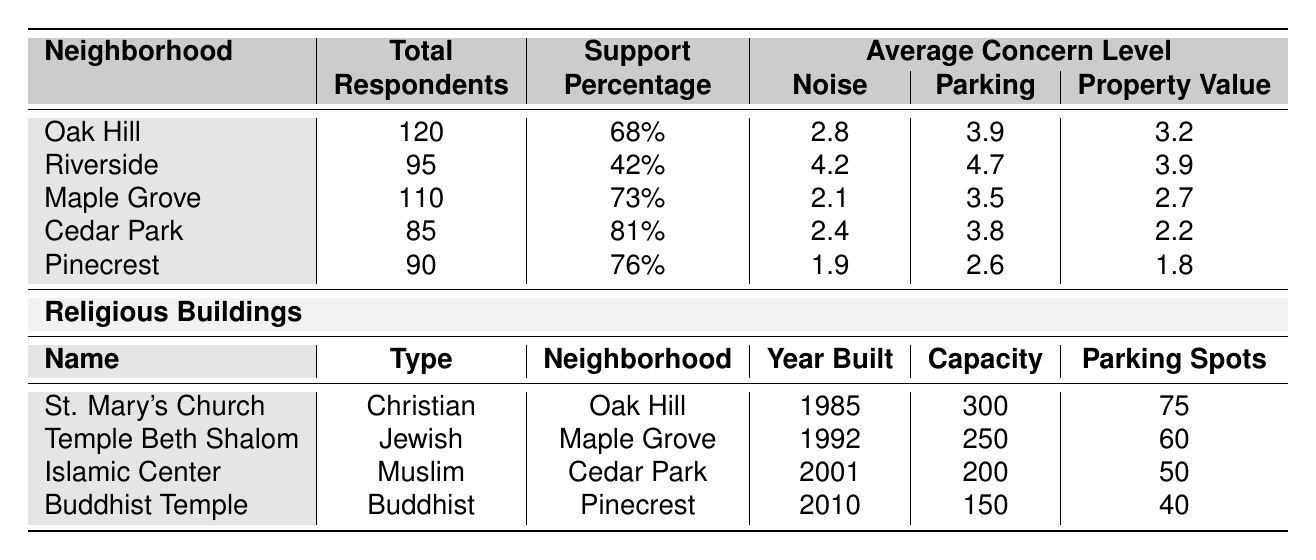What is the total number of respondents from Riverside? The table lists Riverside as having a total of 95 respondents.
Answer: 95 What percentage of respondents from Cedar Park support religious buildings? The support percentage for Cedar Park is indicated as 81%.
Answer: 81% Which neighborhood has the highest average concern about parking? Looking at the average concern levels, Riverside has the highest average concern for parking at 4.7.
Answer: Riverside What is the average concern for property value in the neighborhood of Pinecrest? The table shows that the average concern for property value in Pinecrest is 1.8.
Answer: 1.8 Which religious building has the highest capacity? St. Mary's Church has the highest capacity listed at 300.
Answer: St. Mary's Church How many more respondents support religious buildings in Maple Grove than in Riverside? The support percentage for Maple Grove is 73% and for Riverside is 42%. The difference is 73 - 42 = 31%.
Answer: 31% In which neighborhood is the Islamic Center located, and how many parking spots does it have? The Islamic Center is located in Cedar Park and has 50 parking spots.
Answer: Cedar Park; 50 If we average the average concerns for noise across all neighborhoods, what is that value? Summing the average noise concerns: 2.8 (Oak Hill) + 4.2 (Riverside) + 2.1 (Maple Grove) + 2.4 (Cedar Park) + 1.9 (Pinecrest) = 13.4. Dividing by 5 gives an average of 13.4 / 5 = 2.68.
Answer: 2.68 Is there a neighborhood with no support for religious buildings according to the table? From the data, Riverside has 42% support, so there is no neighborhood with zero support listed.
Answer: No What is the average parking concern in the neighborhood with the lowest support for religious buildings? The lowest support is from Riverside at 42%, and the average parking concern there is 4.7.
Answer: 4.7 How many years apart were St. Mary's Church and the Islamic Center built? St. Mary's Church was built in 1985 and the Islamic Center in 2001. The difference is 2001 - 1985 = 16 years.
Answer: 16 years 